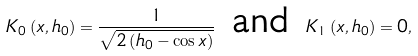<formula> <loc_0><loc_0><loc_500><loc_500>K _ { 0 } \left ( x , h _ { 0 } \right ) = \frac { 1 } { \sqrt { 2 \left ( h _ { 0 } - \cos x \right ) } } \text { and } K _ { 1 } \left ( x , h _ { 0 } \right ) = 0 ,</formula> 